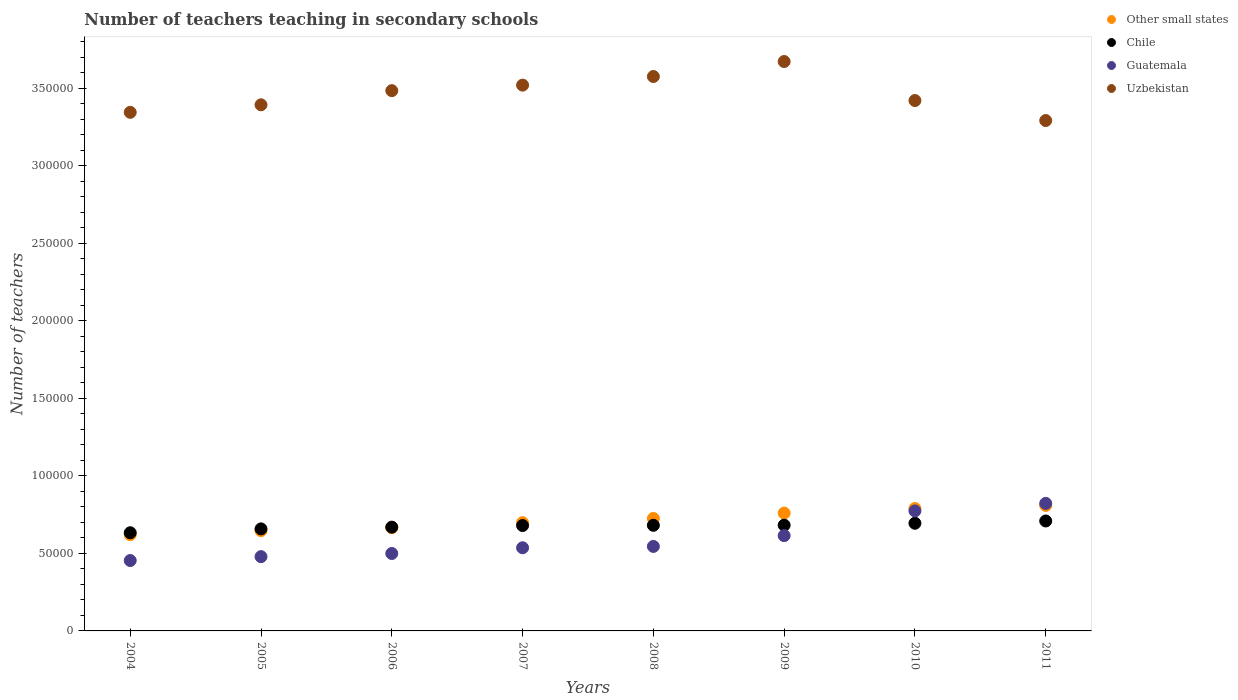How many different coloured dotlines are there?
Provide a short and direct response. 4. What is the number of teachers teaching in secondary schools in Uzbekistan in 2009?
Your response must be concise. 3.67e+05. Across all years, what is the maximum number of teachers teaching in secondary schools in Uzbekistan?
Keep it short and to the point. 3.67e+05. Across all years, what is the minimum number of teachers teaching in secondary schools in Other small states?
Give a very brief answer. 6.21e+04. What is the total number of teachers teaching in secondary schools in Other small states in the graph?
Make the answer very short. 5.72e+05. What is the difference between the number of teachers teaching in secondary schools in Uzbekistan in 2004 and that in 2009?
Your response must be concise. -3.28e+04. What is the difference between the number of teachers teaching in secondary schools in Other small states in 2006 and the number of teachers teaching in secondary schools in Guatemala in 2010?
Provide a short and direct response. -1.08e+04. What is the average number of teachers teaching in secondary schools in Guatemala per year?
Provide a short and direct response. 5.91e+04. In the year 2007, what is the difference between the number of teachers teaching in secondary schools in Uzbekistan and number of teachers teaching in secondary schools in Other small states?
Offer a terse response. 2.82e+05. What is the ratio of the number of teachers teaching in secondary schools in Other small states in 2007 to that in 2009?
Your response must be concise. 0.92. What is the difference between the highest and the second highest number of teachers teaching in secondary schools in Chile?
Provide a short and direct response. 1469. What is the difference between the highest and the lowest number of teachers teaching in secondary schools in Uzbekistan?
Your answer should be very brief. 3.81e+04. In how many years, is the number of teachers teaching in secondary schools in Chile greater than the average number of teachers teaching in secondary schools in Chile taken over all years?
Your answer should be very brief. 5. How many dotlines are there?
Provide a succinct answer. 4. What is the difference between two consecutive major ticks on the Y-axis?
Make the answer very short. 5.00e+04. Are the values on the major ticks of Y-axis written in scientific E-notation?
Offer a very short reply. No. Does the graph contain any zero values?
Make the answer very short. No. Where does the legend appear in the graph?
Make the answer very short. Top right. How many legend labels are there?
Keep it short and to the point. 4. How are the legend labels stacked?
Make the answer very short. Vertical. What is the title of the graph?
Provide a succinct answer. Number of teachers teaching in secondary schools. Does "Honduras" appear as one of the legend labels in the graph?
Keep it short and to the point. No. What is the label or title of the Y-axis?
Provide a short and direct response. Number of teachers. What is the Number of teachers of Other small states in 2004?
Provide a succinct answer. 6.21e+04. What is the Number of teachers of Chile in 2004?
Your answer should be compact. 6.33e+04. What is the Number of teachers of Guatemala in 2004?
Provide a short and direct response. 4.54e+04. What is the Number of teachers in Uzbekistan in 2004?
Provide a short and direct response. 3.34e+05. What is the Number of teachers of Other small states in 2005?
Your response must be concise. 6.47e+04. What is the Number of teachers in Chile in 2005?
Your answer should be compact. 6.58e+04. What is the Number of teachers of Guatemala in 2005?
Ensure brevity in your answer.  4.79e+04. What is the Number of teachers in Uzbekistan in 2005?
Offer a very short reply. 3.39e+05. What is the Number of teachers in Other small states in 2006?
Ensure brevity in your answer.  6.66e+04. What is the Number of teachers of Chile in 2006?
Provide a short and direct response. 6.69e+04. What is the Number of teachers in Guatemala in 2006?
Your answer should be compact. 4.99e+04. What is the Number of teachers of Uzbekistan in 2006?
Your answer should be very brief. 3.48e+05. What is the Number of teachers of Other small states in 2007?
Give a very brief answer. 6.98e+04. What is the Number of teachers in Chile in 2007?
Your response must be concise. 6.80e+04. What is the Number of teachers in Guatemala in 2007?
Give a very brief answer. 5.36e+04. What is the Number of teachers of Uzbekistan in 2007?
Provide a short and direct response. 3.52e+05. What is the Number of teachers in Other small states in 2008?
Provide a short and direct response. 7.25e+04. What is the Number of teachers of Chile in 2008?
Give a very brief answer. 6.81e+04. What is the Number of teachers in Guatemala in 2008?
Provide a short and direct response. 5.45e+04. What is the Number of teachers in Uzbekistan in 2008?
Make the answer very short. 3.58e+05. What is the Number of teachers of Other small states in 2009?
Keep it short and to the point. 7.60e+04. What is the Number of teachers of Chile in 2009?
Provide a succinct answer. 6.82e+04. What is the Number of teachers of Guatemala in 2009?
Your answer should be very brief. 6.15e+04. What is the Number of teachers of Uzbekistan in 2009?
Provide a short and direct response. 3.67e+05. What is the Number of teachers in Other small states in 2010?
Keep it short and to the point. 7.89e+04. What is the Number of teachers in Chile in 2010?
Your response must be concise. 6.94e+04. What is the Number of teachers in Guatemala in 2010?
Provide a succinct answer. 7.74e+04. What is the Number of teachers in Uzbekistan in 2010?
Your answer should be very brief. 3.42e+05. What is the Number of teachers in Other small states in 2011?
Provide a succinct answer. 8.09e+04. What is the Number of teachers of Chile in 2011?
Offer a terse response. 7.09e+04. What is the Number of teachers of Guatemala in 2011?
Provide a succinct answer. 8.22e+04. What is the Number of teachers in Uzbekistan in 2011?
Your answer should be very brief. 3.29e+05. Across all years, what is the maximum Number of teachers of Other small states?
Give a very brief answer. 8.09e+04. Across all years, what is the maximum Number of teachers of Chile?
Your response must be concise. 7.09e+04. Across all years, what is the maximum Number of teachers of Guatemala?
Ensure brevity in your answer.  8.22e+04. Across all years, what is the maximum Number of teachers in Uzbekistan?
Provide a succinct answer. 3.67e+05. Across all years, what is the minimum Number of teachers in Other small states?
Your response must be concise. 6.21e+04. Across all years, what is the minimum Number of teachers of Chile?
Offer a very short reply. 6.33e+04. Across all years, what is the minimum Number of teachers in Guatemala?
Your response must be concise. 4.54e+04. Across all years, what is the minimum Number of teachers in Uzbekistan?
Keep it short and to the point. 3.29e+05. What is the total Number of teachers in Other small states in the graph?
Offer a terse response. 5.72e+05. What is the total Number of teachers of Chile in the graph?
Your response must be concise. 5.41e+05. What is the total Number of teachers in Guatemala in the graph?
Your response must be concise. 4.72e+05. What is the total Number of teachers in Uzbekistan in the graph?
Make the answer very short. 2.77e+06. What is the difference between the Number of teachers in Other small states in 2004 and that in 2005?
Ensure brevity in your answer.  -2598.76. What is the difference between the Number of teachers of Chile in 2004 and that in 2005?
Provide a short and direct response. -2502. What is the difference between the Number of teachers of Guatemala in 2004 and that in 2005?
Provide a succinct answer. -2504. What is the difference between the Number of teachers of Uzbekistan in 2004 and that in 2005?
Make the answer very short. -4854. What is the difference between the Number of teachers in Other small states in 2004 and that in 2006?
Provide a succinct answer. -4520.57. What is the difference between the Number of teachers of Chile in 2004 and that in 2006?
Give a very brief answer. -3616. What is the difference between the Number of teachers in Guatemala in 2004 and that in 2006?
Keep it short and to the point. -4535. What is the difference between the Number of teachers in Uzbekistan in 2004 and that in 2006?
Offer a terse response. -1.40e+04. What is the difference between the Number of teachers in Other small states in 2004 and that in 2007?
Offer a very short reply. -7728.7. What is the difference between the Number of teachers in Chile in 2004 and that in 2007?
Give a very brief answer. -4659. What is the difference between the Number of teachers in Guatemala in 2004 and that in 2007?
Offer a very short reply. -8230. What is the difference between the Number of teachers in Uzbekistan in 2004 and that in 2007?
Your response must be concise. -1.75e+04. What is the difference between the Number of teachers in Other small states in 2004 and that in 2008?
Your answer should be very brief. -1.05e+04. What is the difference between the Number of teachers of Chile in 2004 and that in 2008?
Your answer should be very brief. -4802. What is the difference between the Number of teachers of Guatemala in 2004 and that in 2008?
Give a very brief answer. -9098. What is the difference between the Number of teachers of Uzbekistan in 2004 and that in 2008?
Ensure brevity in your answer.  -2.31e+04. What is the difference between the Number of teachers in Other small states in 2004 and that in 2009?
Your answer should be compact. -1.39e+04. What is the difference between the Number of teachers of Chile in 2004 and that in 2009?
Give a very brief answer. -4889. What is the difference between the Number of teachers of Guatemala in 2004 and that in 2009?
Offer a very short reply. -1.61e+04. What is the difference between the Number of teachers of Uzbekistan in 2004 and that in 2009?
Your answer should be very brief. -3.28e+04. What is the difference between the Number of teachers in Other small states in 2004 and that in 2010?
Give a very brief answer. -1.68e+04. What is the difference between the Number of teachers of Chile in 2004 and that in 2010?
Offer a very short reply. -6123. What is the difference between the Number of teachers of Guatemala in 2004 and that in 2010?
Your answer should be very brief. -3.20e+04. What is the difference between the Number of teachers in Uzbekistan in 2004 and that in 2010?
Provide a succinct answer. -7603. What is the difference between the Number of teachers of Other small states in 2004 and that in 2011?
Your answer should be compact. -1.89e+04. What is the difference between the Number of teachers of Chile in 2004 and that in 2011?
Keep it short and to the point. -7592. What is the difference between the Number of teachers of Guatemala in 2004 and that in 2011?
Your answer should be compact. -3.68e+04. What is the difference between the Number of teachers in Uzbekistan in 2004 and that in 2011?
Give a very brief answer. 5293. What is the difference between the Number of teachers of Other small states in 2005 and that in 2006?
Offer a very short reply. -1921.81. What is the difference between the Number of teachers of Chile in 2005 and that in 2006?
Keep it short and to the point. -1114. What is the difference between the Number of teachers in Guatemala in 2005 and that in 2006?
Provide a succinct answer. -2031. What is the difference between the Number of teachers of Uzbekistan in 2005 and that in 2006?
Ensure brevity in your answer.  -9130. What is the difference between the Number of teachers in Other small states in 2005 and that in 2007?
Your response must be concise. -5129.94. What is the difference between the Number of teachers in Chile in 2005 and that in 2007?
Your response must be concise. -2157. What is the difference between the Number of teachers of Guatemala in 2005 and that in 2007?
Your answer should be very brief. -5726. What is the difference between the Number of teachers of Uzbekistan in 2005 and that in 2007?
Make the answer very short. -1.27e+04. What is the difference between the Number of teachers in Other small states in 2005 and that in 2008?
Provide a short and direct response. -7857.45. What is the difference between the Number of teachers in Chile in 2005 and that in 2008?
Offer a very short reply. -2300. What is the difference between the Number of teachers in Guatemala in 2005 and that in 2008?
Your answer should be compact. -6594. What is the difference between the Number of teachers in Uzbekistan in 2005 and that in 2008?
Offer a terse response. -1.82e+04. What is the difference between the Number of teachers in Other small states in 2005 and that in 2009?
Your answer should be very brief. -1.13e+04. What is the difference between the Number of teachers in Chile in 2005 and that in 2009?
Your answer should be very brief. -2387. What is the difference between the Number of teachers in Guatemala in 2005 and that in 2009?
Your answer should be compact. -1.36e+04. What is the difference between the Number of teachers in Uzbekistan in 2005 and that in 2009?
Offer a terse response. -2.79e+04. What is the difference between the Number of teachers of Other small states in 2005 and that in 2010?
Give a very brief answer. -1.42e+04. What is the difference between the Number of teachers of Chile in 2005 and that in 2010?
Give a very brief answer. -3621. What is the difference between the Number of teachers in Guatemala in 2005 and that in 2010?
Offer a terse response. -2.95e+04. What is the difference between the Number of teachers of Uzbekistan in 2005 and that in 2010?
Make the answer very short. -2749. What is the difference between the Number of teachers in Other small states in 2005 and that in 2011?
Provide a short and direct response. -1.63e+04. What is the difference between the Number of teachers in Chile in 2005 and that in 2011?
Provide a succinct answer. -5090. What is the difference between the Number of teachers of Guatemala in 2005 and that in 2011?
Make the answer very short. -3.43e+04. What is the difference between the Number of teachers of Uzbekistan in 2005 and that in 2011?
Keep it short and to the point. 1.01e+04. What is the difference between the Number of teachers in Other small states in 2006 and that in 2007?
Offer a terse response. -3208.12. What is the difference between the Number of teachers in Chile in 2006 and that in 2007?
Offer a very short reply. -1043. What is the difference between the Number of teachers in Guatemala in 2006 and that in 2007?
Keep it short and to the point. -3695. What is the difference between the Number of teachers of Uzbekistan in 2006 and that in 2007?
Make the answer very short. -3556. What is the difference between the Number of teachers of Other small states in 2006 and that in 2008?
Your answer should be compact. -5935.64. What is the difference between the Number of teachers of Chile in 2006 and that in 2008?
Give a very brief answer. -1186. What is the difference between the Number of teachers of Guatemala in 2006 and that in 2008?
Your answer should be very brief. -4563. What is the difference between the Number of teachers of Uzbekistan in 2006 and that in 2008?
Offer a terse response. -9115. What is the difference between the Number of teachers of Other small states in 2006 and that in 2009?
Your answer should be compact. -9394.62. What is the difference between the Number of teachers in Chile in 2006 and that in 2009?
Make the answer very short. -1273. What is the difference between the Number of teachers of Guatemala in 2006 and that in 2009?
Give a very brief answer. -1.15e+04. What is the difference between the Number of teachers in Uzbekistan in 2006 and that in 2009?
Give a very brief answer. -1.88e+04. What is the difference between the Number of teachers of Other small states in 2006 and that in 2010?
Provide a succinct answer. -1.23e+04. What is the difference between the Number of teachers of Chile in 2006 and that in 2010?
Offer a very short reply. -2507. What is the difference between the Number of teachers in Guatemala in 2006 and that in 2010?
Make the answer very short. -2.75e+04. What is the difference between the Number of teachers in Uzbekistan in 2006 and that in 2010?
Provide a succinct answer. 6381. What is the difference between the Number of teachers of Other small states in 2006 and that in 2011?
Your response must be concise. -1.43e+04. What is the difference between the Number of teachers of Chile in 2006 and that in 2011?
Keep it short and to the point. -3976. What is the difference between the Number of teachers in Guatemala in 2006 and that in 2011?
Keep it short and to the point. -3.23e+04. What is the difference between the Number of teachers in Uzbekistan in 2006 and that in 2011?
Give a very brief answer. 1.93e+04. What is the difference between the Number of teachers of Other small states in 2007 and that in 2008?
Give a very brief answer. -2727.52. What is the difference between the Number of teachers of Chile in 2007 and that in 2008?
Offer a terse response. -143. What is the difference between the Number of teachers in Guatemala in 2007 and that in 2008?
Ensure brevity in your answer.  -868. What is the difference between the Number of teachers in Uzbekistan in 2007 and that in 2008?
Keep it short and to the point. -5559. What is the difference between the Number of teachers in Other small states in 2007 and that in 2009?
Offer a very short reply. -6186.5. What is the difference between the Number of teachers in Chile in 2007 and that in 2009?
Provide a succinct answer. -230. What is the difference between the Number of teachers in Guatemala in 2007 and that in 2009?
Make the answer very short. -7842. What is the difference between the Number of teachers of Uzbekistan in 2007 and that in 2009?
Keep it short and to the point. -1.52e+04. What is the difference between the Number of teachers of Other small states in 2007 and that in 2010?
Ensure brevity in your answer.  -9118.38. What is the difference between the Number of teachers in Chile in 2007 and that in 2010?
Offer a very short reply. -1464. What is the difference between the Number of teachers of Guatemala in 2007 and that in 2010?
Offer a very short reply. -2.38e+04. What is the difference between the Number of teachers in Uzbekistan in 2007 and that in 2010?
Provide a short and direct response. 9937. What is the difference between the Number of teachers of Other small states in 2007 and that in 2011?
Give a very brief answer. -1.11e+04. What is the difference between the Number of teachers of Chile in 2007 and that in 2011?
Your response must be concise. -2933. What is the difference between the Number of teachers of Guatemala in 2007 and that in 2011?
Provide a short and direct response. -2.86e+04. What is the difference between the Number of teachers in Uzbekistan in 2007 and that in 2011?
Your response must be concise. 2.28e+04. What is the difference between the Number of teachers of Other small states in 2008 and that in 2009?
Offer a very short reply. -3458.98. What is the difference between the Number of teachers in Chile in 2008 and that in 2009?
Give a very brief answer. -87. What is the difference between the Number of teachers in Guatemala in 2008 and that in 2009?
Keep it short and to the point. -6974. What is the difference between the Number of teachers in Uzbekistan in 2008 and that in 2009?
Provide a short and direct response. -9664. What is the difference between the Number of teachers in Other small states in 2008 and that in 2010?
Offer a very short reply. -6390.87. What is the difference between the Number of teachers in Chile in 2008 and that in 2010?
Make the answer very short. -1321. What is the difference between the Number of teachers in Guatemala in 2008 and that in 2010?
Your answer should be very brief. -2.29e+04. What is the difference between the Number of teachers of Uzbekistan in 2008 and that in 2010?
Keep it short and to the point. 1.55e+04. What is the difference between the Number of teachers of Other small states in 2008 and that in 2011?
Offer a very short reply. -8408.55. What is the difference between the Number of teachers in Chile in 2008 and that in 2011?
Your answer should be compact. -2790. What is the difference between the Number of teachers of Guatemala in 2008 and that in 2011?
Provide a succinct answer. -2.78e+04. What is the difference between the Number of teachers in Uzbekistan in 2008 and that in 2011?
Keep it short and to the point. 2.84e+04. What is the difference between the Number of teachers of Other small states in 2009 and that in 2010?
Ensure brevity in your answer.  -2931.88. What is the difference between the Number of teachers of Chile in 2009 and that in 2010?
Offer a terse response. -1234. What is the difference between the Number of teachers of Guatemala in 2009 and that in 2010?
Your answer should be compact. -1.59e+04. What is the difference between the Number of teachers in Uzbekistan in 2009 and that in 2010?
Offer a very short reply. 2.52e+04. What is the difference between the Number of teachers in Other small states in 2009 and that in 2011?
Make the answer very short. -4949.56. What is the difference between the Number of teachers of Chile in 2009 and that in 2011?
Your answer should be very brief. -2703. What is the difference between the Number of teachers of Guatemala in 2009 and that in 2011?
Give a very brief answer. -2.08e+04. What is the difference between the Number of teachers of Uzbekistan in 2009 and that in 2011?
Provide a short and direct response. 3.81e+04. What is the difference between the Number of teachers of Other small states in 2010 and that in 2011?
Offer a very short reply. -2017.68. What is the difference between the Number of teachers of Chile in 2010 and that in 2011?
Ensure brevity in your answer.  -1469. What is the difference between the Number of teachers in Guatemala in 2010 and that in 2011?
Give a very brief answer. -4850. What is the difference between the Number of teachers of Uzbekistan in 2010 and that in 2011?
Your response must be concise. 1.29e+04. What is the difference between the Number of teachers in Other small states in 2004 and the Number of teachers in Chile in 2005?
Ensure brevity in your answer.  -3732.55. What is the difference between the Number of teachers in Other small states in 2004 and the Number of teachers in Guatemala in 2005?
Keep it short and to the point. 1.42e+04. What is the difference between the Number of teachers of Other small states in 2004 and the Number of teachers of Uzbekistan in 2005?
Provide a succinct answer. -2.77e+05. What is the difference between the Number of teachers in Chile in 2004 and the Number of teachers in Guatemala in 2005?
Provide a short and direct response. 1.54e+04. What is the difference between the Number of teachers of Chile in 2004 and the Number of teachers of Uzbekistan in 2005?
Offer a very short reply. -2.76e+05. What is the difference between the Number of teachers in Guatemala in 2004 and the Number of teachers in Uzbekistan in 2005?
Provide a succinct answer. -2.94e+05. What is the difference between the Number of teachers of Other small states in 2004 and the Number of teachers of Chile in 2006?
Offer a terse response. -4846.55. What is the difference between the Number of teachers in Other small states in 2004 and the Number of teachers in Guatemala in 2006?
Your response must be concise. 1.21e+04. What is the difference between the Number of teachers of Other small states in 2004 and the Number of teachers of Uzbekistan in 2006?
Your answer should be very brief. -2.86e+05. What is the difference between the Number of teachers of Chile in 2004 and the Number of teachers of Guatemala in 2006?
Your answer should be compact. 1.34e+04. What is the difference between the Number of teachers in Chile in 2004 and the Number of teachers in Uzbekistan in 2006?
Ensure brevity in your answer.  -2.85e+05. What is the difference between the Number of teachers in Guatemala in 2004 and the Number of teachers in Uzbekistan in 2006?
Make the answer very short. -3.03e+05. What is the difference between the Number of teachers in Other small states in 2004 and the Number of teachers in Chile in 2007?
Your answer should be compact. -5889.55. What is the difference between the Number of teachers in Other small states in 2004 and the Number of teachers in Guatemala in 2007?
Keep it short and to the point. 8450.45. What is the difference between the Number of teachers of Other small states in 2004 and the Number of teachers of Uzbekistan in 2007?
Give a very brief answer. -2.90e+05. What is the difference between the Number of teachers in Chile in 2004 and the Number of teachers in Guatemala in 2007?
Provide a short and direct response. 9681. What is the difference between the Number of teachers in Chile in 2004 and the Number of teachers in Uzbekistan in 2007?
Give a very brief answer. -2.89e+05. What is the difference between the Number of teachers of Guatemala in 2004 and the Number of teachers of Uzbekistan in 2007?
Provide a short and direct response. -3.07e+05. What is the difference between the Number of teachers of Other small states in 2004 and the Number of teachers of Chile in 2008?
Make the answer very short. -6032.55. What is the difference between the Number of teachers of Other small states in 2004 and the Number of teachers of Guatemala in 2008?
Offer a terse response. 7582.45. What is the difference between the Number of teachers in Other small states in 2004 and the Number of teachers in Uzbekistan in 2008?
Keep it short and to the point. -2.95e+05. What is the difference between the Number of teachers of Chile in 2004 and the Number of teachers of Guatemala in 2008?
Your response must be concise. 8813. What is the difference between the Number of teachers of Chile in 2004 and the Number of teachers of Uzbekistan in 2008?
Your answer should be very brief. -2.94e+05. What is the difference between the Number of teachers of Guatemala in 2004 and the Number of teachers of Uzbekistan in 2008?
Ensure brevity in your answer.  -3.12e+05. What is the difference between the Number of teachers of Other small states in 2004 and the Number of teachers of Chile in 2009?
Make the answer very short. -6119.55. What is the difference between the Number of teachers of Other small states in 2004 and the Number of teachers of Guatemala in 2009?
Offer a terse response. 608.45. What is the difference between the Number of teachers of Other small states in 2004 and the Number of teachers of Uzbekistan in 2009?
Your answer should be compact. -3.05e+05. What is the difference between the Number of teachers in Chile in 2004 and the Number of teachers in Guatemala in 2009?
Ensure brevity in your answer.  1839. What is the difference between the Number of teachers in Chile in 2004 and the Number of teachers in Uzbekistan in 2009?
Offer a terse response. -3.04e+05. What is the difference between the Number of teachers of Guatemala in 2004 and the Number of teachers of Uzbekistan in 2009?
Offer a very short reply. -3.22e+05. What is the difference between the Number of teachers of Other small states in 2004 and the Number of teachers of Chile in 2010?
Ensure brevity in your answer.  -7353.55. What is the difference between the Number of teachers in Other small states in 2004 and the Number of teachers in Guatemala in 2010?
Keep it short and to the point. -1.53e+04. What is the difference between the Number of teachers in Other small states in 2004 and the Number of teachers in Uzbekistan in 2010?
Provide a short and direct response. -2.80e+05. What is the difference between the Number of teachers of Chile in 2004 and the Number of teachers of Guatemala in 2010?
Offer a very short reply. -1.41e+04. What is the difference between the Number of teachers in Chile in 2004 and the Number of teachers in Uzbekistan in 2010?
Offer a very short reply. -2.79e+05. What is the difference between the Number of teachers in Guatemala in 2004 and the Number of teachers in Uzbekistan in 2010?
Your answer should be very brief. -2.97e+05. What is the difference between the Number of teachers of Other small states in 2004 and the Number of teachers of Chile in 2011?
Your response must be concise. -8822.55. What is the difference between the Number of teachers of Other small states in 2004 and the Number of teachers of Guatemala in 2011?
Make the answer very short. -2.02e+04. What is the difference between the Number of teachers in Other small states in 2004 and the Number of teachers in Uzbekistan in 2011?
Your answer should be very brief. -2.67e+05. What is the difference between the Number of teachers in Chile in 2004 and the Number of teachers in Guatemala in 2011?
Your answer should be very brief. -1.89e+04. What is the difference between the Number of teachers in Chile in 2004 and the Number of teachers in Uzbekistan in 2011?
Your answer should be compact. -2.66e+05. What is the difference between the Number of teachers in Guatemala in 2004 and the Number of teachers in Uzbekistan in 2011?
Keep it short and to the point. -2.84e+05. What is the difference between the Number of teachers in Other small states in 2005 and the Number of teachers in Chile in 2006?
Provide a short and direct response. -2247.79. What is the difference between the Number of teachers in Other small states in 2005 and the Number of teachers in Guatemala in 2006?
Offer a terse response. 1.47e+04. What is the difference between the Number of teachers in Other small states in 2005 and the Number of teachers in Uzbekistan in 2006?
Your response must be concise. -2.84e+05. What is the difference between the Number of teachers of Chile in 2005 and the Number of teachers of Guatemala in 2006?
Provide a short and direct response. 1.59e+04. What is the difference between the Number of teachers of Chile in 2005 and the Number of teachers of Uzbekistan in 2006?
Provide a succinct answer. -2.83e+05. What is the difference between the Number of teachers in Guatemala in 2005 and the Number of teachers in Uzbekistan in 2006?
Your response must be concise. -3.01e+05. What is the difference between the Number of teachers of Other small states in 2005 and the Number of teachers of Chile in 2007?
Offer a very short reply. -3290.79. What is the difference between the Number of teachers in Other small states in 2005 and the Number of teachers in Guatemala in 2007?
Your answer should be compact. 1.10e+04. What is the difference between the Number of teachers in Other small states in 2005 and the Number of teachers in Uzbekistan in 2007?
Your response must be concise. -2.87e+05. What is the difference between the Number of teachers in Chile in 2005 and the Number of teachers in Guatemala in 2007?
Ensure brevity in your answer.  1.22e+04. What is the difference between the Number of teachers in Chile in 2005 and the Number of teachers in Uzbekistan in 2007?
Give a very brief answer. -2.86e+05. What is the difference between the Number of teachers in Guatemala in 2005 and the Number of teachers in Uzbekistan in 2007?
Your response must be concise. -3.04e+05. What is the difference between the Number of teachers of Other small states in 2005 and the Number of teachers of Chile in 2008?
Your response must be concise. -3433.79. What is the difference between the Number of teachers in Other small states in 2005 and the Number of teachers in Guatemala in 2008?
Ensure brevity in your answer.  1.02e+04. What is the difference between the Number of teachers of Other small states in 2005 and the Number of teachers of Uzbekistan in 2008?
Give a very brief answer. -2.93e+05. What is the difference between the Number of teachers in Chile in 2005 and the Number of teachers in Guatemala in 2008?
Your answer should be compact. 1.13e+04. What is the difference between the Number of teachers in Chile in 2005 and the Number of teachers in Uzbekistan in 2008?
Make the answer very short. -2.92e+05. What is the difference between the Number of teachers of Guatemala in 2005 and the Number of teachers of Uzbekistan in 2008?
Your answer should be very brief. -3.10e+05. What is the difference between the Number of teachers of Other small states in 2005 and the Number of teachers of Chile in 2009?
Give a very brief answer. -3520.79. What is the difference between the Number of teachers in Other small states in 2005 and the Number of teachers in Guatemala in 2009?
Your answer should be very brief. 3207.21. What is the difference between the Number of teachers in Other small states in 2005 and the Number of teachers in Uzbekistan in 2009?
Give a very brief answer. -3.03e+05. What is the difference between the Number of teachers of Chile in 2005 and the Number of teachers of Guatemala in 2009?
Ensure brevity in your answer.  4341. What is the difference between the Number of teachers of Chile in 2005 and the Number of teachers of Uzbekistan in 2009?
Your answer should be compact. -3.01e+05. What is the difference between the Number of teachers of Guatemala in 2005 and the Number of teachers of Uzbekistan in 2009?
Provide a short and direct response. -3.19e+05. What is the difference between the Number of teachers in Other small states in 2005 and the Number of teachers in Chile in 2010?
Offer a very short reply. -4754.79. What is the difference between the Number of teachers of Other small states in 2005 and the Number of teachers of Guatemala in 2010?
Ensure brevity in your answer.  -1.27e+04. What is the difference between the Number of teachers of Other small states in 2005 and the Number of teachers of Uzbekistan in 2010?
Give a very brief answer. -2.77e+05. What is the difference between the Number of teachers in Chile in 2005 and the Number of teachers in Guatemala in 2010?
Your answer should be very brief. -1.16e+04. What is the difference between the Number of teachers in Chile in 2005 and the Number of teachers in Uzbekistan in 2010?
Offer a very short reply. -2.76e+05. What is the difference between the Number of teachers in Guatemala in 2005 and the Number of teachers in Uzbekistan in 2010?
Your answer should be very brief. -2.94e+05. What is the difference between the Number of teachers of Other small states in 2005 and the Number of teachers of Chile in 2011?
Provide a succinct answer. -6223.79. What is the difference between the Number of teachers of Other small states in 2005 and the Number of teachers of Guatemala in 2011?
Provide a succinct answer. -1.76e+04. What is the difference between the Number of teachers of Other small states in 2005 and the Number of teachers of Uzbekistan in 2011?
Offer a terse response. -2.64e+05. What is the difference between the Number of teachers in Chile in 2005 and the Number of teachers in Guatemala in 2011?
Make the answer very short. -1.64e+04. What is the difference between the Number of teachers in Chile in 2005 and the Number of teachers in Uzbekistan in 2011?
Offer a very short reply. -2.63e+05. What is the difference between the Number of teachers of Guatemala in 2005 and the Number of teachers of Uzbekistan in 2011?
Keep it short and to the point. -2.81e+05. What is the difference between the Number of teachers in Other small states in 2006 and the Number of teachers in Chile in 2007?
Your answer should be very brief. -1368.98. What is the difference between the Number of teachers of Other small states in 2006 and the Number of teachers of Guatemala in 2007?
Provide a succinct answer. 1.30e+04. What is the difference between the Number of teachers of Other small states in 2006 and the Number of teachers of Uzbekistan in 2007?
Give a very brief answer. -2.85e+05. What is the difference between the Number of teachers of Chile in 2006 and the Number of teachers of Guatemala in 2007?
Your response must be concise. 1.33e+04. What is the difference between the Number of teachers in Chile in 2006 and the Number of teachers in Uzbekistan in 2007?
Your response must be concise. -2.85e+05. What is the difference between the Number of teachers of Guatemala in 2006 and the Number of teachers of Uzbekistan in 2007?
Ensure brevity in your answer.  -3.02e+05. What is the difference between the Number of teachers in Other small states in 2006 and the Number of teachers in Chile in 2008?
Keep it short and to the point. -1511.98. What is the difference between the Number of teachers in Other small states in 2006 and the Number of teachers in Guatemala in 2008?
Give a very brief answer. 1.21e+04. What is the difference between the Number of teachers of Other small states in 2006 and the Number of teachers of Uzbekistan in 2008?
Offer a terse response. -2.91e+05. What is the difference between the Number of teachers of Chile in 2006 and the Number of teachers of Guatemala in 2008?
Make the answer very short. 1.24e+04. What is the difference between the Number of teachers of Chile in 2006 and the Number of teachers of Uzbekistan in 2008?
Provide a short and direct response. -2.91e+05. What is the difference between the Number of teachers of Guatemala in 2006 and the Number of teachers of Uzbekistan in 2008?
Offer a terse response. -3.08e+05. What is the difference between the Number of teachers of Other small states in 2006 and the Number of teachers of Chile in 2009?
Your response must be concise. -1598.98. What is the difference between the Number of teachers in Other small states in 2006 and the Number of teachers in Guatemala in 2009?
Offer a very short reply. 5129.02. What is the difference between the Number of teachers of Other small states in 2006 and the Number of teachers of Uzbekistan in 2009?
Offer a very short reply. -3.01e+05. What is the difference between the Number of teachers of Chile in 2006 and the Number of teachers of Guatemala in 2009?
Offer a terse response. 5455. What is the difference between the Number of teachers in Chile in 2006 and the Number of teachers in Uzbekistan in 2009?
Your answer should be compact. -3.00e+05. What is the difference between the Number of teachers of Guatemala in 2006 and the Number of teachers of Uzbekistan in 2009?
Ensure brevity in your answer.  -3.17e+05. What is the difference between the Number of teachers of Other small states in 2006 and the Number of teachers of Chile in 2010?
Give a very brief answer. -2832.98. What is the difference between the Number of teachers in Other small states in 2006 and the Number of teachers in Guatemala in 2010?
Give a very brief answer. -1.08e+04. What is the difference between the Number of teachers of Other small states in 2006 and the Number of teachers of Uzbekistan in 2010?
Keep it short and to the point. -2.75e+05. What is the difference between the Number of teachers of Chile in 2006 and the Number of teachers of Guatemala in 2010?
Offer a very short reply. -1.05e+04. What is the difference between the Number of teachers of Chile in 2006 and the Number of teachers of Uzbekistan in 2010?
Provide a short and direct response. -2.75e+05. What is the difference between the Number of teachers of Guatemala in 2006 and the Number of teachers of Uzbekistan in 2010?
Your answer should be compact. -2.92e+05. What is the difference between the Number of teachers in Other small states in 2006 and the Number of teachers in Chile in 2011?
Your response must be concise. -4301.98. What is the difference between the Number of teachers of Other small states in 2006 and the Number of teachers of Guatemala in 2011?
Provide a succinct answer. -1.56e+04. What is the difference between the Number of teachers in Other small states in 2006 and the Number of teachers in Uzbekistan in 2011?
Give a very brief answer. -2.63e+05. What is the difference between the Number of teachers in Chile in 2006 and the Number of teachers in Guatemala in 2011?
Offer a very short reply. -1.53e+04. What is the difference between the Number of teachers of Chile in 2006 and the Number of teachers of Uzbekistan in 2011?
Your answer should be very brief. -2.62e+05. What is the difference between the Number of teachers of Guatemala in 2006 and the Number of teachers of Uzbekistan in 2011?
Offer a very short reply. -2.79e+05. What is the difference between the Number of teachers of Other small states in 2007 and the Number of teachers of Chile in 2008?
Your answer should be very brief. 1696.15. What is the difference between the Number of teachers in Other small states in 2007 and the Number of teachers in Guatemala in 2008?
Your answer should be compact. 1.53e+04. What is the difference between the Number of teachers in Other small states in 2007 and the Number of teachers in Uzbekistan in 2008?
Provide a succinct answer. -2.88e+05. What is the difference between the Number of teachers in Chile in 2007 and the Number of teachers in Guatemala in 2008?
Offer a very short reply. 1.35e+04. What is the difference between the Number of teachers of Chile in 2007 and the Number of teachers of Uzbekistan in 2008?
Ensure brevity in your answer.  -2.90e+05. What is the difference between the Number of teachers of Guatemala in 2007 and the Number of teachers of Uzbekistan in 2008?
Ensure brevity in your answer.  -3.04e+05. What is the difference between the Number of teachers in Other small states in 2007 and the Number of teachers in Chile in 2009?
Provide a succinct answer. 1609.15. What is the difference between the Number of teachers in Other small states in 2007 and the Number of teachers in Guatemala in 2009?
Give a very brief answer. 8337.15. What is the difference between the Number of teachers of Other small states in 2007 and the Number of teachers of Uzbekistan in 2009?
Your response must be concise. -2.97e+05. What is the difference between the Number of teachers in Chile in 2007 and the Number of teachers in Guatemala in 2009?
Provide a succinct answer. 6498. What is the difference between the Number of teachers of Chile in 2007 and the Number of teachers of Uzbekistan in 2009?
Provide a short and direct response. -2.99e+05. What is the difference between the Number of teachers in Guatemala in 2007 and the Number of teachers in Uzbekistan in 2009?
Ensure brevity in your answer.  -3.14e+05. What is the difference between the Number of teachers in Other small states in 2007 and the Number of teachers in Chile in 2010?
Your response must be concise. 375.15. What is the difference between the Number of teachers of Other small states in 2007 and the Number of teachers of Guatemala in 2010?
Your answer should be compact. -7590.85. What is the difference between the Number of teachers of Other small states in 2007 and the Number of teachers of Uzbekistan in 2010?
Give a very brief answer. -2.72e+05. What is the difference between the Number of teachers in Chile in 2007 and the Number of teachers in Guatemala in 2010?
Provide a succinct answer. -9430. What is the difference between the Number of teachers of Chile in 2007 and the Number of teachers of Uzbekistan in 2010?
Ensure brevity in your answer.  -2.74e+05. What is the difference between the Number of teachers of Guatemala in 2007 and the Number of teachers of Uzbekistan in 2010?
Your response must be concise. -2.88e+05. What is the difference between the Number of teachers in Other small states in 2007 and the Number of teachers in Chile in 2011?
Offer a terse response. -1093.85. What is the difference between the Number of teachers of Other small states in 2007 and the Number of teachers of Guatemala in 2011?
Offer a very short reply. -1.24e+04. What is the difference between the Number of teachers of Other small states in 2007 and the Number of teachers of Uzbekistan in 2011?
Provide a short and direct response. -2.59e+05. What is the difference between the Number of teachers of Chile in 2007 and the Number of teachers of Guatemala in 2011?
Give a very brief answer. -1.43e+04. What is the difference between the Number of teachers of Chile in 2007 and the Number of teachers of Uzbekistan in 2011?
Provide a short and direct response. -2.61e+05. What is the difference between the Number of teachers of Guatemala in 2007 and the Number of teachers of Uzbekistan in 2011?
Offer a terse response. -2.76e+05. What is the difference between the Number of teachers in Other small states in 2008 and the Number of teachers in Chile in 2009?
Provide a short and direct response. 4336.66. What is the difference between the Number of teachers of Other small states in 2008 and the Number of teachers of Guatemala in 2009?
Offer a very short reply. 1.11e+04. What is the difference between the Number of teachers in Other small states in 2008 and the Number of teachers in Uzbekistan in 2009?
Your answer should be compact. -2.95e+05. What is the difference between the Number of teachers of Chile in 2008 and the Number of teachers of Guatemala in 2009?
Keep it short and to the point. 6641. What is the difference between the Number of teachers in Chile in 2008 and the Number of teachers in Uzbekistan in 2009?
Keep it short and to the point. -2.99e+05. What is the difference between the Number of teachers in Guatemala in 2008 and the Number of teachers in Uzbekistan in 2009?
Ensure brevity in your answer.  -3.13e+05. What is the difference between the Number of teachers of Other small states in 2008 and the Number of teachers of Chile in 2010?
Your answer should be very brief. 3102.66. What is the difference between the Number of teachers in Other small states in 2008 and the Number of teachers in Guatemala in 2010?
Provide a short and direct response. -4863.34. What is the difference between the Number of teachers in Other small states in 2008 and the Number of teachers in Uzbekistan in 2010?
Keep it short and to the point. -2.70e+05. What is the difference between the Number of teachers in Chile in 2008 and the Number of teachers in Guatemala in 2010?
Your answer should be very brief. -9287. What is the difference between the Number of teachers of Chile in 2008 and the Number of teachers of Uzbekistan in 2010?
Offer a very short reply. -2.74e+05. What is the difference between the Number of teachers of Guatemala in 2008 and the Number of teachers of Uzbekistan in 2010?
Give a very brief answer. -2.88e+05. What is the difference between the Number of teachers of Other small states in 2008 and the Number of teachers of Chile in 2011?
Give a very brief answer. 1633.66. What is the difference between the Number of teachers of Other small states in 2008 and the Number of teachers of Guatemala in 2011?
Provide a succinct answer. -9713.34. What is the difference between the Number of teachers of Other small states in 2008 and the Number of teachers of Uzbekistan in 2011?
Provide a succinct answer. -2.57e+05. What is the difference between the Number of teachers in Chile in 2008 and the Number of teachers in Guatemala in 2011?
Your answer should be compact. -1.41e+04. What is the difference between the Number of teachers in Chile in 2008 and the Number of teachers in Uzbekistan in 2011?
Your answer should be compact. -2.61e+05. What is the difference between the Number of teachers in Guatemala in 2008 and the Number of teachers in Uzbekistan in 2011?
Provide a short and direct response. -2.75e+05. What is the difference between the Number of teachers in Other small states in 2009 and the Number of teachers in Chile in 2010?
Keep it short and to the point. 6561.65. What is the difference between the Number of teachers of Other small states in 2009 and the Number of teachers of Guatemala in 2010?
Your answer should be very brief. -1404.35. What is the difference between the Number of teachers of Other small states in 2009 and the Number of teachers of Uzbekistan in 2010?
Provide a succinct answer. -2.66e+05. What is the difference between the Number of teachers in Chile in 2009 and the Number of teachers in Guatemala in 2010?
Provide a short and direct response. -9200. What is the difference between the Number of teachers in Chile in 2009 and the Number of teachers in Uzbekistan in 2010?
Ensure brevity in your answer.  -2.74e+05. What is the difference between the Number of teachers in Guatemala in 2009 and the Number of teachers in Uzbekistan in 2010?
Your response must be concise. -2.81e+05. What is the difference between the Number of teachers of Other small states in 2009 and the Number of teachers of Chile in 2011?
Keep it short and to the point. 5092.65. What is the difference between the Number of teachers in Other small states in 2009 and the Number of teachers in Guatemala in 2011?
Make the answer very short. -6254.35. What is the difference between the Number of teachers of Other small states in 2009 and the Number of teachers of Uzbekistan in 2011?
Provide a succinct answer. -2.53e+05. What is the difference between the Number of teachers of Chile in 2009 and the Number of teachers of Guatemala in 2011?
Your answer should be compact. -1.40e+04. What is the difference between the Number of teachers of Chile in 2009 and the Number of teachers of Uzbekistan in 2011?
Your answer should be compact. -2.61e+05. What is the difference between the Number of teachers of Guatemala in 2009 and the Number of teachers of Uzbekistan in 2011?
Your answer should be compact. -2.68e+05. What is the difference between the Number of teachers in Other small states in 2010 and the Number of teachers in Chile in 2011?
Offer a very short reply. 8024.53. What is the difference between the Number of teachers in Other small states in 2010 and the Number of teachers in Guatemala in 2011?
Offer a terse response. -3322.47. What is the difference between the Number of teachers of Other small states in 2010 and the Number of teachers of Uzbekistan in 2011?
Your response must be concise. -2.50e+05. What is the difference between the Number of teachers in Chile in 2010 and the Number of teachers in Guatemala in 2011?
Provide a short and direct response. -1.28e+04. What is the difference between the Number of teachers of Chile in 2010 and the Number of teachers of Uzbekistan in 2011?
Your answer should be compact. -2.60e+05. What is the difference between the Number of teachers in Guatemala in 2010 and the Number of teachers in Uzbekistan in 2011?
Offer a terse response. -2.52e+05. What is the average Number of teachers in Other small states per year?
Provide a short and direct response. 7.14e+04. What is the average Number of teachers of Chile per year?
Make the answer very short. 6.76e+04. What is the average Number of teachers of Guatemala per year?
Offer a terse response. 5.91e+04. What is the average Number of teachers of Uzbekistan per year?
Your answer should be very brief. 3.46e+05. In the year 2004, what is the difference between the Number of teachers in Other small states and Number of teachers in Chile?
Keep it short and to the point. -1230.55. In the year 2004, what is the difference between the Number of teachers in Other small states and Number of teachers in Guatemala?
Give a very brief answer. 1.67e+04. In the year 2004, what is the difference between the Number of teachers of Other small states and Number of teachers of Uzbekistan?
Your answer should be very brief. -2.72e+05. In the year 2004, what is the difference between the Number of teachers in Chile and Number of teachers in Guatemala?
Give a very brief answer. 1.79e+04. In the year 2004, what is the difference between the Number of teachers of Chile and Number of teachers of Uzbekistan?
Give a very brief answer. -2.71e+05. In the year 2004, what is the difference between the Number of teachers in Guatemala and Number of teachers in Uzbekistan?
Ensure brevity in your answer.  -2.89e+05. In the year 2005, what is the difference between the Number of teachers of Other small states and Number of teachers of Chile?
Provide a short and direct response. -1133.79. In the year 2005, what is the difference between the Number of teachers of Other small states and Number of teachers of Guatemala?
Offer a very short reply. 1.68e+04. In the year 2005, what is the difference between the Number of teachers of Other small states and Number of teachers of Uzbekistan?
Keep it short and to the point. -2.75e+05. In the year 2005, what is the difference between the Number of teachers in Chile and Number of teachers in Guatemala?
Your response must be concise. 1.79e+04. In the year 2005, what is the difference between the Number of teachers in Chile and Number of teachers in Uzbekistan?
Give a very brief answer. -2.74e+05. In the year 2005, what is the difference between the Number of teachers in Guatemala and Number of teachers in Uzbekistan?
Offer a very short reply. -2.91e+05. In the year 2006, what is the difference between the Number of teachers in Other small states and Number of teachers in Chile?
Give a very brief answer. -325.98. In the year 2006, what is the difference between the Number of teachers of Other small states and Number of teachers of Guatemala?
Your answer should be very brief. 1.67e+04. In the year 2006, what is the difference between the Number of teachers in Other small states and Number of teachers in Uzbekistan?
Give a very brief answer. -2.82e+05. In the year 2006, what is the difference between the Number of teachers of Chile and Number of teachers of Guatemala?
Give a very brief answer. 1.70e+04. In the year 2006, what is the difference between the Number of teachers in Chile and Number of teachers in Uzbekistan?
Offer a very short reply. -2.82e+05. In the year 2006, what is the difference between the Number of teachers of Guatemala and Number of teachers of Uzbekistan?
Ensure brevity in your answer.  -2.99e+05. In the year 2007, what is the difference between the Number of teachers in Other small states and Number of teachers in Chile?
Provide a succinct answer. 1839.15. In the year 2007, what is the difference between the Number of teachers in Other small states and Number of teachers in Guatemala?
Ensure brevity in your answer.  1.62e+04. In the year 2007, what is the difference between the Number of teachers in Other small states and Number of teachers in Uzbekistan?
Give a very brief answer. -2.82e+05. In the year 2007, what is the difference between the Number of teachers in Chile and Number of teachers in Guatemala?
Your answer should be very brief. 1.43e+04. In the year 2007, what is the difference between the Number of teachers of Chile and Number of teachers of Uzbekistan?
Give a very brief answer. -2.84e+05. In the year 2007, what is the difference between the Number of teachers in Guatemala and Number of teachers in Uzbekistan?
Make the answer very short. -2.98e+05. In the year 2008, what is the difference between the Number of teachers in Other small states and Number of teachers in Chile?
Offer a terse response. 4423.66. In the year 2008, what is the difference between the Number of teachers of Other small states and Number of teachers of Guatemala?
Your response must be concise. 1.80e+04. In the year 2008, what is the difference between the Number of teachers of Other small states and Number of teachers of Uzbekistan?
Give a very brief answer. -2.85e+05. In the year 2008, what is the difference between the Number of teachers of Chile and Number of teachers of Guatemala?
Provide a short and direct response. 1.36e+04. In the year 2008, what is the difference between the Number of teachers in Chile and Number of teachers in Uzbekistan?
Make the answer very short. -2.89e+05. In the year 2008, what is the difference between the Number of teachers of Guatemala and Number of teachers of Uzbekistan?
Your answer should be very brief. -3.03e+05. In the year 2009, what is the difference between the Number of teachers of Other small states and Number of teachers of Chile?
Your answer should be very brief. 7795.65. In the year 2009, what is the difference between the Number of teachers in Other small states and Number of teachers in Guatemala?
Keep it short and to the point. 1.45e+04. In the year 2009, what is the difference between the Number of teachers in Other small states and Number of teachers in Uzbekistan?
Make the answer very short. -2.91e+05. In the year 2009, what is the difference between the Number of teachers of Chile and Number of teachers of Guatemala?
Offer a very short reply. 6728. In the year 2009, what is the difference between the Number of teachers in Chile and Number of teachers in Uzbekistan?
Your answer should be compact. -2.99e+05. In the year 2009, what is the difference between the Number of teachers of Guatemala and Number of teachers of Uzbekistan?
Provide a succinct answer. -3.06e+05. In the year 2010, what is the difference between the Number of teachers of Other small states and Number of teachers of Chile?
Give a very brief answer. 9493.53. In the year 2010, what is the difference between the Number of teachers in Other small states and Number of teachers in Guatemala?
Offer a very short reply. 1527.53. In the year 2010, what is the difference between the Number of teachers in Other small states and Number of teachers in Uzbekistan?
Your response must be concise. -2.63e+05. In the year 2010, what is the difference between the Number of teachers of Chile and Number of teachers of Guatemala?
Your answer should be compact. -7966. In the year 2010, what is the difference between the Number of teachers in Chile and Number of teachers in Uzbekistan?
Provide a short and direct response. -2.73e+05. In the year 2010, what is the difference between the Number of teachers in Guatemala and Number of teachers in Uzbekistan?
Your response must be concise. -2.65e+05. In the year 2011, what is the difference between the Number of teachers in Other small states and Number of teachers in Chile?
Make the answer very short. 1.00e+04. In the year 2011, what is the difference between the Number of teachers of Other small states and Number of teachers of Guatemala?
Provide a short and direct response. -1304.79. In the year 2011, what is the difference between the Number of teachers of Other small states and Number of teachers of Uzbekistan?
Give a very brief answer. -2.48e+05. In the year 2011, what is the difference between the Number of teachers in Chile and Number of teachers in Guatemala?
Provide a short and direct response. -1.13e+04. In the year 2011, what is the difference between the Number of teachers of Chile and Number of teachers of Uzbekistan?
Provide a succinct answer. -2.58e+05. In the year 2011, what is the difference between the Number of teachers in Guatemala and Number of teachers in Uzbekistan?
Provide a short and direct response. -2.47e+05. What is the ratio of the Number of teachers of Other small states in 2004 to that in 2005?
Provide a short and direct response. 0.96. What is the ratio of the Number of teachers in Guatemala in 2004 to that in 2005?
Your response must be concise. 0.95. What is the ratio of the Number of teachers in Uzbekistan in 2004 to that in 2005?
Provide a short and direct response. 0.99. What is the ratio of the Number of teachers in Other small states in 2004 to that in 2006?
Ensure brevity in your answer.  0.93. What is the ratio of the Number of teachers in Chile in 2004 to that in 2006?
Make the answer very short. 0.95. What is the ratio of the Number of teachers of Guatemala in 2004 to that in 2006?
Provide a succinct answer. 0.91. What is the ratio of the Number of teachers in Uzbekistan in 2004 to that in 2006?
Give a very brief answer. 0.96. What is the ratio of the Number of teachers of Other small states in 2004 to that in 2007?
Provide a short and direct response. 0.89. What is the ratio of the Number of teachers of Chile in 2004 to that in 2007?
Make the answer very short. 0.93. What is the ratio of the Number of teachers of Guatemala in 2004 to that in 2007?
Provide a short and direct response. 0.85. What is the ratio of the Number of teachers in Uzbekistan in 2004 to that in 2007?
Your response must be concise. 0.95. What is the ratio of the Number of teachers in Other small states in 2004 to that in 2008?
Make the answer very short. 0.86. What is the ratio of the Number of teachers in Chile in 2004 to that in 2008?
Your answer should be compact. 0.93. What is the ratio of the Number of teachers of Guatemala in 2004 to that in 2008?
Provide a short and direct response. 0.83. What is the ratio of the Number of teachers in Uzbekistan in 2004 to that in 2008?
Offer a terse response. 0.94. What is the ratio of the Number of teachers of Other small states in 2004 to that in 2009?
Provide a succinct answer. 0.82. What is the ratio of the Number of teachers of Chile in 2004 to that in 2009?
Provide a short and direct response. 0.93. What is the ratio of the Number of teachers of Guatemala in 2004 to that in 2009?
Your answer should be compact. 0.74. What is the ratio of the Number of teachers in Uzbekistan in 2004 to that in 2009?
Give a very brief answer. 0.91. What is the ratio of the Number of teachers in Other small states in 2004 to that in 2010?
Your answer should be very brief. 0.79. What is the ratio of the Number of teachers in Chile in 2004 to that in 2010?
Your answer should be compact. 0.91. What is the ratio of the Number of teachers of Guatemala in 2004 to that in 2010?
Your answer should be very brief. 0.59. What is the ratio of the Number of teachers of Uzbekistan in 2004 to that in 2010?
Provide a short and direct response. 0.98. What is the ratio of the Number of teachers of Other small states in 2004 to that in 2011?
Your answer should be very brief. 0.77. What is the ratio of the Number of teachers of Chile in 2004 to that in 2011?
Ensure brevity in your answer.  0.89. What is the ratio of the Number of teachers in Guatemala in 2004 to that in 2011?
Make the answer very short. 0.55. What is the ratio of the Number of teachers of Uzbekistan in 2004 to that in 2011?
Ensure brevity in your answer.  1.02. What is the ratio of the Number of teachers in Other small states in 2005 to that in 2006?
Keep it short and to the point. 0.97. What is the ratio of the Number of teachers in Chile in 2005 to that in 2006?
Make the answer very short. 0.98. What is the ratio of the Number of teachers of Guatemala in 2005 to that in 2006?
Your answer should be very brief. 0.96. What is the ratio of the Number of teachers of Uzbekistan in 2005 to that in 2006?
Your answer should be very brief. 0.97. What is the ratio of the Number of teachers in Other small states in 2005 to that in 2007?
Offer a terse response. 0.93. What is the ratio of the Number of teachers in Chile in 2005 to that in 2007?
Ensure brevity in your answer.  0.97. What is the ratio of the Number of teachers in Guatemala in 2005 to that in 2007?
Ensure brevity in your answer.  0.89. What is the ratio of the Number of teachers in Other small states in 2005 to that in 2008?
Offer a terse response. 0.89. What is the ratio of the Number of teachers of Chile in 2005 to that in 2008?
Provide a succinct answer. 0.97. What is the ratio of the Number of teachers in Guatemala in 2005 to that in 2008?
Provide a short and direct response. 0.88. What is the ratio of the Number of teachers of Uzbekistan in 2005 to that in 2008?
Your response must be concise. 0.95. What is the ratio of the Number of teachers of Other small states in 2005 to that in 2009?
Your response must be concise. 0.85. What is the ratio of the Number of teachers in Guatemala in 2005 to that in 2009?
Your answer should be very brief. 0.78. What is the ratio of the Number of teachers of Uzbekistan in 2005 to that in 2009?
Keep it short and to the point. 0.92. What is the ratio of the Number of teachers in Other small states in 2005 to that in 2010?
Provide a short and direct response. 0.82. What is the ratio of the Number of teachers of Chile in 2005 to that in 2010?
Make the answer very short. 0.95. What is the ratio of the Number of teachers in Guatemala in 2005 to that in 2010?
Your answer should be compact. 0.62. What is the ratio of the Number of teachers of Uzbekistan in 2005 to that in 2010?
Your answer should be compact. 0.99. What is the ratio of the Number of teachers in Other small states in 2005 to that in 2011?
Give a very brief answer. 0.8. What is the ratio of the Number of teachers of Chile in 2005 to that in 2011?
Offer a very short reply. 0.93. What is the ratio of the Number of teachers of Guatemala in 2005 to that in 2011?
Offer a terse response. 0.58. What is the ratio of the Number of teachers of Uzbekistan in 2005 to that in 2011?
Make the answer very short. 1.03. What is the ratio of the Number of teachers of Other small states in 2006 to that in 2007?
Make the answer very short. 0.95. What is the ratio of the Number of teachers in Chile in 2006 to that in 2007?
Make the answer very short. 0.98. What is the ratio of the Number of teachers in Guatemala in 2006 to that in 2007?
Your answer should be compact. 0.93. What is the ratio of the Number of teachers in Other small states in 2006 to that in 2008?
Offer a very short reply. 0.92. What is the ratio of the Number of teachers in Chile in 2006 to that in 2008?
Your answer should be very brief. 0.98. What is the ratio of the Number of teachers of Guatemala in 2006 to that in 2008?
Your response must be concise. 0.92. What is the ratio of the Number of teachers of Uzbekistan in 2006 to that in 2008?
Make the answer very short. 0.97. What is the ratio of the Number of teachers of Other small states in 2006 to that in 2009?
Provide a short and direct response. 0.88. What is the ratio of the Number of teachers of Chile in 2006 to that in 2009?
Ensure brevity in your answer.  0.98. What is the ratio of the Number of teachers in Guatemala in 2006 to that in 2009?
Your answer should be compact. 0.81. What is the ratio of the Number of teachers of Uzbekistan in 2006 to that in 2009?
Provide a succinct answer. 0.95. What is the ratio of the Number of teachers of Other small states in 2006 to that in 2010?
Your response must be concise. 0.84. What is the ratio of the Number of teachers in Chile in 2006 to that in 2010?
Your answer should be compact. 0.96. What is the ratio of the Number of teachers of Guatemala in 2006 to that in 2010?
Your answer should be compact. 0.65. What is the ratio of the Number of teachers of Uzbekistan in 2006 to that in 2010?
Give a very brief answer. 1.02. What is the ratio of the Number of teachers of Other small states in 2006 to that in 2011?
Your response must be concise. 0.82. What is the ratio of the Number of teachers in Chile in 2006 to that in 2011?
Make the answer very short. 0.94. What is the ratio of the Number of teachers of Guatemala in 2006 to that in 2011?
Make the answer very short. 0.61. What is the ratio of the Number of teachers of Uzbekistan in 2006 to that in 2011?
Your response must be concise. 1.06. What is the ratio of the Number of teachers of Other small states in 2007 to that in 2008?
Make the answer very short. 0.96. What is the ratio of the Number of teachers of Guatemala in 2007 to that in 2008?
Make the answer very short. 0.98. What is the ratio of the Number of teachers in Uzbekistan in 2007 to that in 2008?
Ensure brevity in your answer.  0.98. What is the ratio of the Number of teachers of Other small states in 2007 to that in 2009?
Offer a very short reply. 0.92. What is the ratio of the Number of teachers in Guatemala in 2007 to that in 2009?
Offer a very short reply. 0.87. What is the ratio of the Number of teachers of Uzbekistan in 2007 to that in 2009?
Your response must be concise. 0.96. What is the ratio of the Number of teachers in Other small states in 2007 to that in 2010?
Keep it short and to the point. 0.88. What is the ratio of the Number of teachers of Chile in 2007 to that in 2010?
Provide a succinct answer. 0.98. What is the ratio of the Number of teachers in Guatemala in 2007 to that in 2010?
Ensure brevity in your answer.  0.69. What is the ratio of the Number of teachers of Uzbekistan in 2007 to that in 2010?
Your answer should be compact. 1.03. What is the ratio of the Number of teachers of Other small states in 2007 to that in 2011?
Your answer should be compact. 0.86. What is the ratio of the Number of teachers in Chile in 2007 to that in 2011?
Your response must be concise. 0.96. What is the ratio of the Number of teachers in Guatemala in 2007 to that in 2011?
Your answer should be compact. 0.65. What is the ratio of the Number of teachers of Uzbekistan in 2007 to that in 2011?
Ensure brevity in your answer.  1.07. What is the ratio of the Number of teachers in Other small states in 2008 to that in 2009?
Provide a succinct answer. 0.95. What is the ratio of the Number of teachers of Guatemala in 2008 to that in 2009?
Ensure brevity in your answer.  0.89. What is the ratio of the Number of teachers of Uzbekistan in 2008 to that in 2009?
Keep it short and to the point. 0.97. What is the ratio of the Number of teachers of Other small states in 2008 to that in 2010?
Provide a short and direct response. 0.92. What is the ratio of the Number of teachers in Guatemala in 2008 to that in 2010?
Ensure brevity in your answer.  0.7. What is the ratio of the Number of teachers of Uzbekistan in 2008 to that in 2010?
Give a very brief answer. 1.05. What is the ratio of the Number of teachers of Other small states in 2008 to that in 2011?
Your response must be concise. 0.9. What is the ratio of the Number of teachers of Chile in 2008 to that in 2011?
Your response must be concise. 0.96. What is the ratio of the Number of teachers of Guatemala in 2008 to that in 2011?
Offer a terse response. 0.66. What is the ratio of the Number of teachers of Uzbekistan in 2008 to that in 2011?
Provide a succinct answer. 1.09. What is the ratio of the Number of teachers of Other small states in 2009 to that in 2010?
Provide a succinct answer. 0.96. What is the ratio of the Number of teachers of Chile in 2009 to that in 2010?
Offer a terse response. 0.98. What is the ratio of the Number of teachers in Guatemala in 2009 to that in 2010?
Your response must be concise. 0.79. What is the ratio of the Number of teachers in Uzbekistan in 2009 to that in 2010?
Make the answer very short. 1.07. What is the ratio of the Number of teachers in Other small states in 2009 to that in 2011?
Keep it short and to the point. 0.94. What is the ratio of the Number of teachers of Chile in 2009 to that in 2011?
Provide a succinct answer. 0.96. What is the ratio of the Number of teachers of Guatemala in 2009 to that in 2011?
Ensure brevity in your answer.  0.75. What is the ratio of the Number of teachers of Uzbekistan in 2009 to that in 2011?
Offer a very short reply. 1.12. What is the ratio of the Number of teachers in Other small states in 2010 to that in 2011?
Your answer should be very brief. 0.98. What is the ratio of the Number of teachers in Chile in 2010 to that in 2011?
Offer a terse response. 0.98. What is the ratio of the Number of teachers in Guatemala in 2010 to that in 2011?
Make the answer very short. 0.94. What is the ratio of the Number of teachers in Uzbekistan in 2010 to that in 2011?
Ensure brevity in your answer.  1.04. What is the difference between the highest and the second highest Number of teachers in Other small states?
Ensure brevity in your answer.  2017.68. What is the difference between the highest and the second highest Number of teachers of Chile?
Your answer should be compact. 1469. What is the difference between the highest and the second highest Number of teachers of Guatemala?
Your response must be concise. 4850. What is the difference between the highest and the second highest Number of teachers of Uzbekistan?
Your answer should be very brief. 9664. What is the difference between the highest and the lowest Number of teachers in Other small states?
Keep it short and to the point. 1.89e+04. What is the difference between the highest and the lowest Number of teachers in Chile?
Offer a very short reply. 7592. What is the difference between the highest and the lowest Number of teachers of Guatemala?
Provide a succinct answer. 3.68e+04. What is the difference between the highest and the lowest Number of teachers of Uzbekistan?
Make the answer very short. 3.81e+04. 